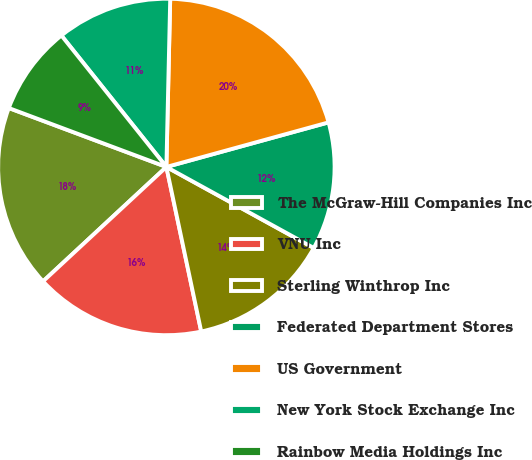Convert chart. <chart><loc_0><loc_0><loc_500><loc_500><pie_chart><fcel>The McGraw-Hill Companies Inc<fcel>VNU Inc<fcel>Sterling Winthrop Inc<fcel>Federated Department Stores<fcel>US Government<fcel>New York Stock Exchange Inc<fcel>Rainbow Media Holdings Inc<nl><fcel>17.6%<fcel>16.42%<fcel>13.68%<fcel>12.27%<fcel>20.37%<fcel>11.09%<fcel>8.58%<nl></chart> 